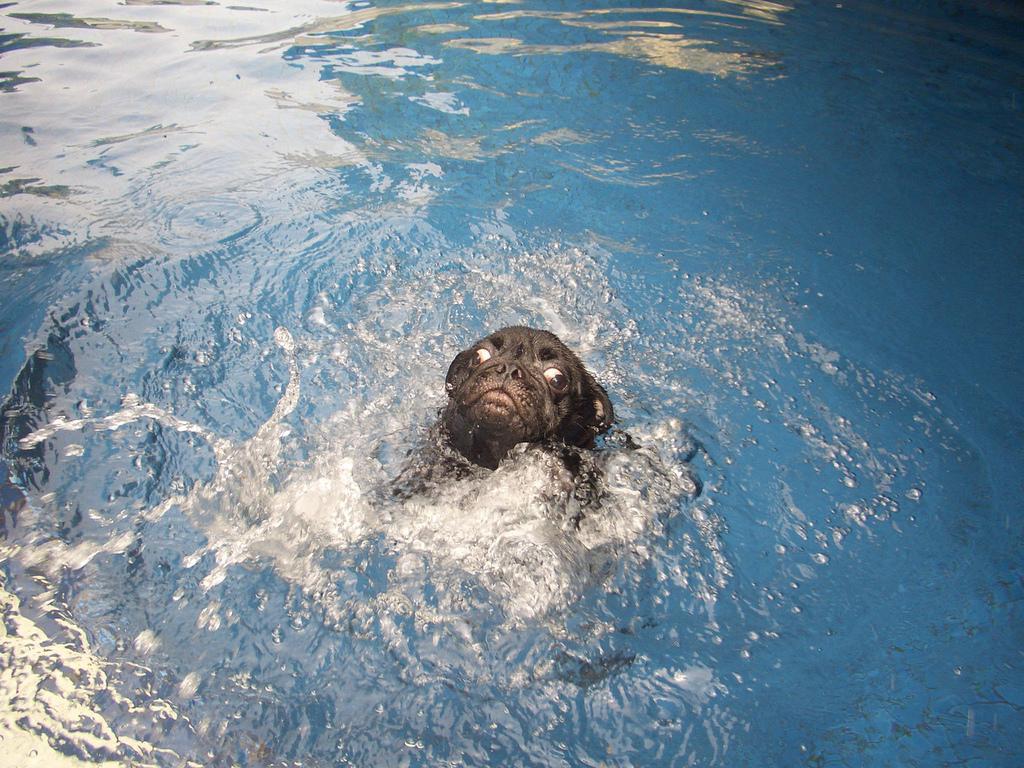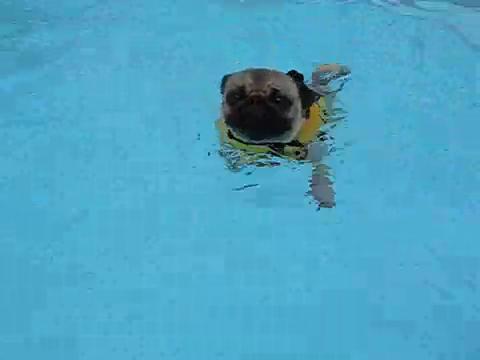The first image is the image on the left, the second image is the image on the right. For the images shown, is this caption "Only one of the images shows a dog in the water." true? Answer yes or no. No. The first image is the image on the left, the second image is the image on the right. Assess this claim about the two images: "In both of the images there is a dog in a swimming pool.". Correct or not? Answer yes or no. Yes. 